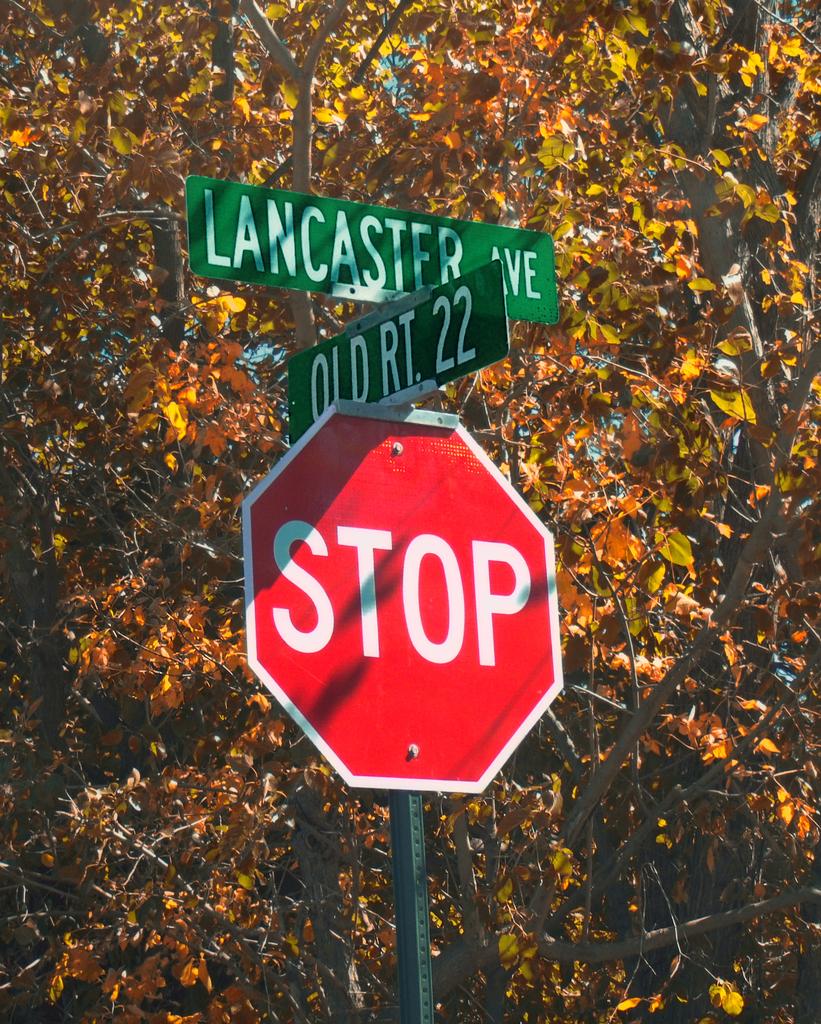What streets are at this intersection?
Offer a very short reply. Lancaster old rt 22. What kind of sign is that?
Keep it short and to the point. Stop. 